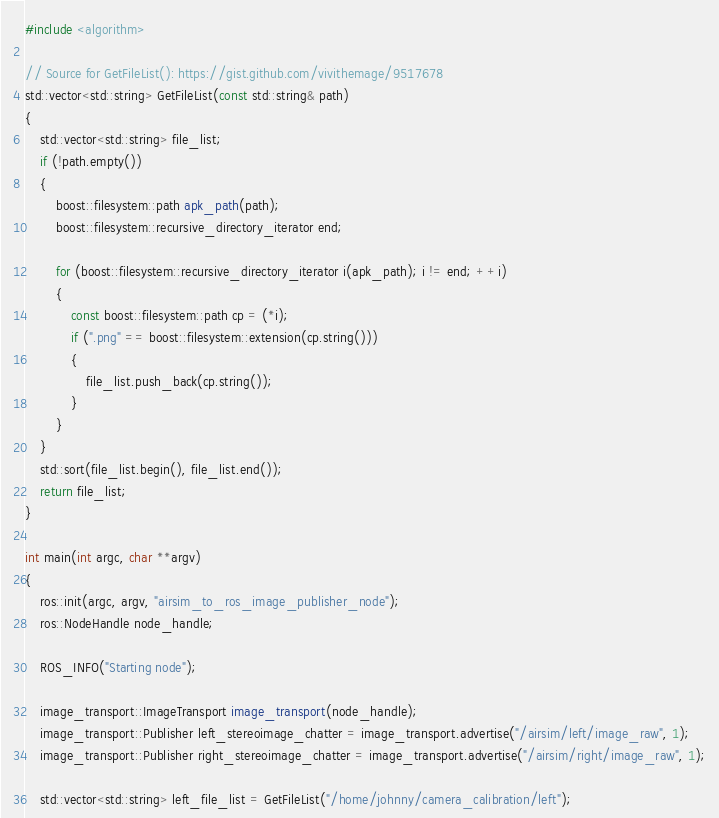<code> <loc_0><loc_0><loc_500><loc_500><_C++_>#include <algorithm>

// Source for GetFileList(): https://gist.github.com/vivithemage/9517678
std::vector<std::string> GetFileList(const std::string& path)
{
    std::vector<std::string> file_list;
    if (!path.empty())
    {
        boost::filesystem::path apk_path(path);
        boost::filesystem::recursive_directory_iterator end;

        for (boost::filesystem::recursive_directory_iterator i(apk_path); i != end; ++i)
        {
            const boost::filesystem::path cp = (*i);
            if (".png" == boost::filesystem::extension(cp.string()))
            {
                file_list.push_back(cp.string());
            }
        }
    }
    std::sort(file_list.begin(), file_list.end());
    return file_list;
}

int main(int argc, char **argv)
{
    ros::init(argc, argv, "airsim_to_ros_image_publisher_node");
    ros::NodeHandle node_handle;
    
    ROS_INFO("Starting node");

    image_transport::ImageTransport image_transport(node_handle);
    image_transport::Publisher left_stereoimage_chatter = image_transport.advertise("/airsim/left/image_raw", 1);
    image_transport::Publisher right_stereoimage_chatter = image_transport.advertise("/airsim/right/image_raw", 1);

    std::vector<std::string> left_file_list = GetFileList("/home/johnny/camera_calibration/left");</code> 